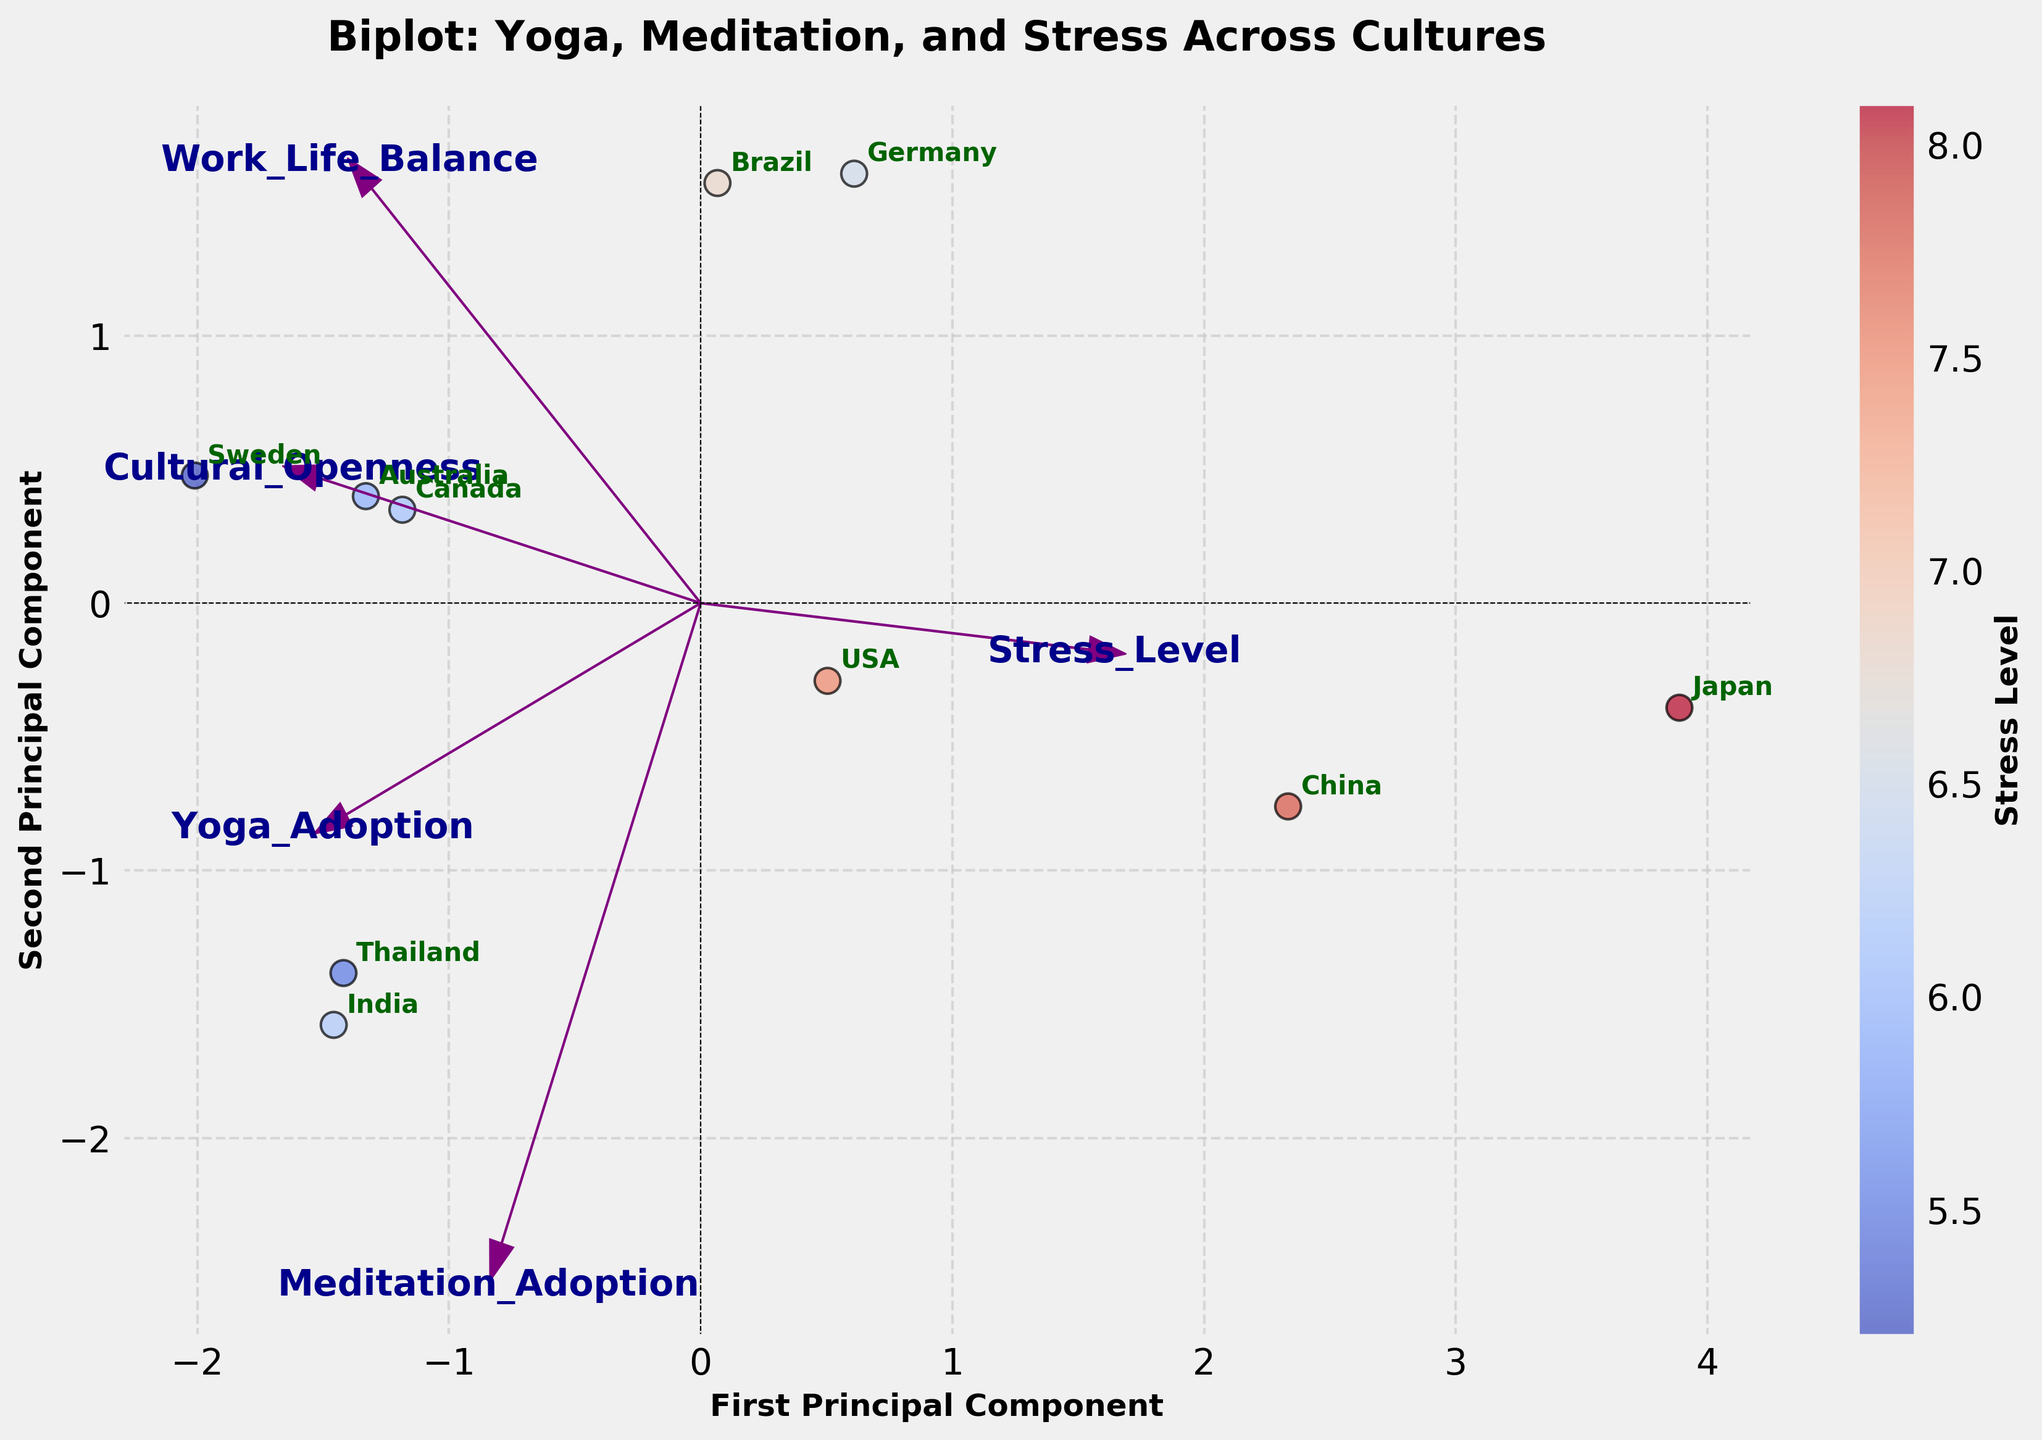How many countries are represented in the biplot? There are individual data points, each representing a different country. Count the distinct labels.
Answer: 10 What are the axis labels, and what do they represent? Read the labels directly from the x-axis and y-axis of the plot.
Answer: First Principal Component, Second Principal Component Which country is associated with the highest stress level? Locate the data point with the darkest color, which represents the highest stress level. The annotation near this data point provides the country name.
Answer: Japan Is Yoga adoption more correlated with the first or second principal component? Look at the direction of the arrow for Yoga_Adoption and see if it is more aligned with the first principal component (horizontal axis) or the second principal component (vertical axis).
Answer: First Principal Component Which feature vector shows the highest projection on the second principal component? Observe the arrows and find which one extends the highest along the second principal component (vertical axis).
Answer: Meditation_Adoption Are there any countries with similar positions on the biplot? If so, name one pair. Finding countries that are close together in the biplot space suggests they share similar adoption rates and stress levels.
Answer: Canada and USA Which feature is most aligned with cultural openness? Look at the direction of the arrow labeled "Cultural_Openness" and determine which principal component it aligns with most.
Answer: Second Principal Component Identify a country with high work-life balance but moderate stress level, judging by its position on the biplot. Find the data point in the plot where "Work_Life_Balance" is high (likely more positive on the first principal component) and "Stress_Level" is moderate (not too darkly colored). Read off the country label.
Answer: Sweden Which country shows the highest adoption rate for Meditation? Locate the country whose projection aligns most closely with the direction of the Meditation_Adoption vector. Read the country label.
Answer: Thailand Based on the arrows' directions, which features seem to be inversely related? Arrows pointing in nearly opposite directions indicate an inverse relationship between their corresponding features.
Answer: Work_Life_Balance and Stress_Level 